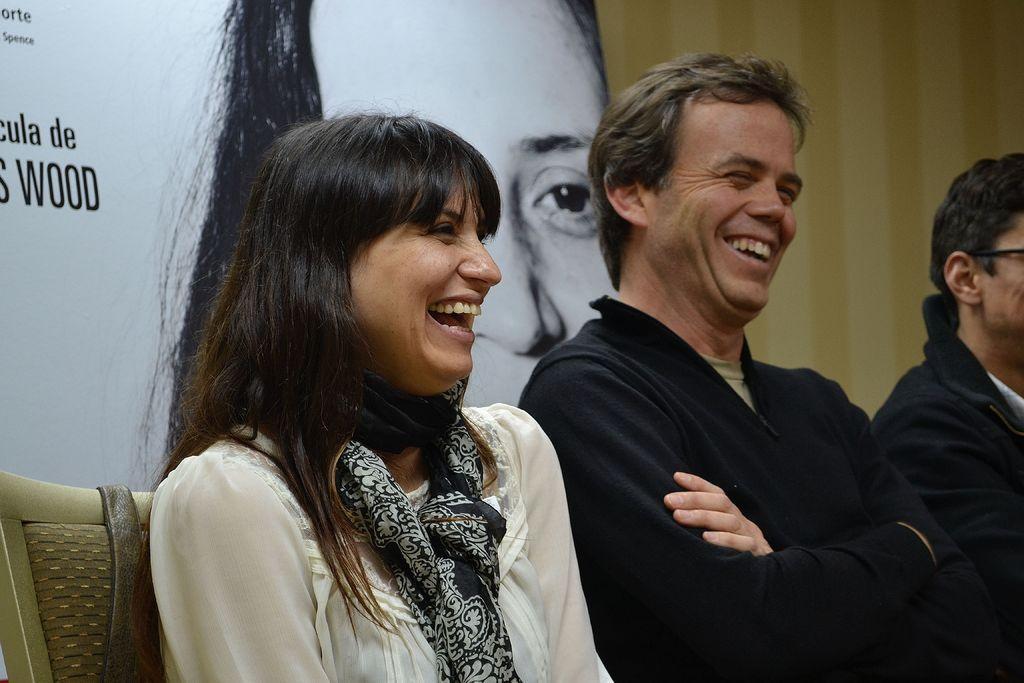Can you describe this image briefly? In this image we can see two men and one women are sitting on chairs. The woman is wearing a white color top with a black scarf. The men are wearing black color jackets. Behind them, we can see one banner and wall. On the banner, some text and one woman image is present 